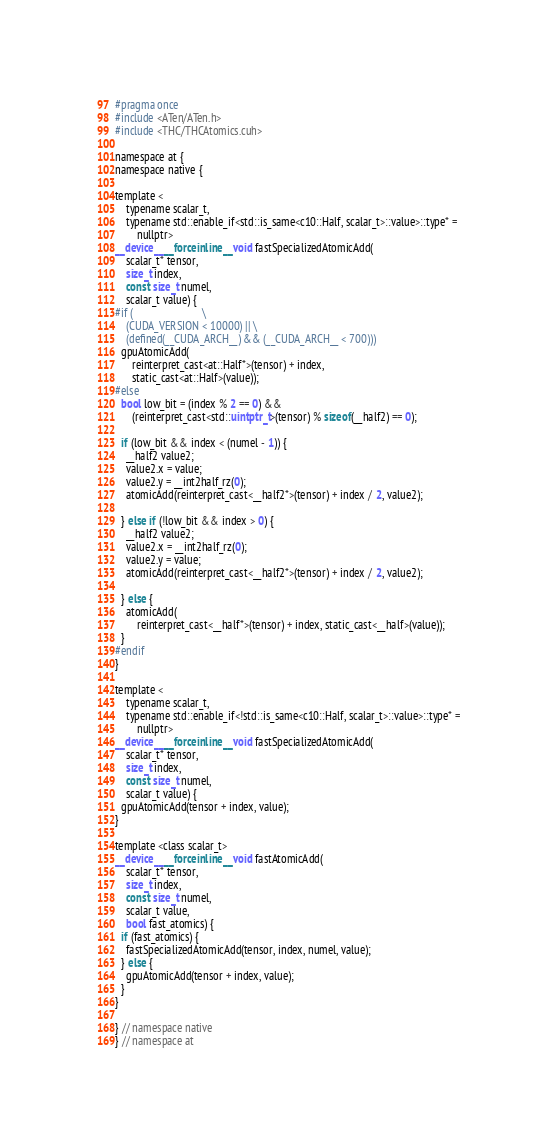<code> <loc_0><loc_0><loc_500><loc_500><_Cuda_>#pragma once
#include <ATen/ATen.h>
#include <THC/THCAtomics.cuh>

namespace at {
namespace native {

template <
    typename scalar_t,
    typename std::enable_if<std::is_same<c10::Half, scalar_t>::value>::type* =
        nullptr>
__device__ __forceinline__ void fastSpecializedAtomicAdd(
    scalar_t* tensor,
    size_t index,
    const size_t numel,
    scalar_t value) {
#if (                         \
    (CUDA_VERSION < 10000) || \
    (defined(__CUDA_ARCH__) && (__CUDA_ARCH__ < 700)))
  gpuAtomicAdd(
      reinterpret_cast<at::Half*>(tensor) + index,
      static_cast<at::Half>(value));
#else
  bool low_bit = (index % 2 == 0) &&
      (reinterpret_cast<std::uintptr_t>(tensor) % sizeof(__half2) == 0);

  if (low_bit && index < (numel - 1)) {
    __half2 value2;
    value2.x = value;
    value2.y = __int2half_rz(0);
    atomicAdd(reinterpret_cast<__half2*>(tensor) + index / 2, value2);

  } else if (!low_bit && index > 0) {
    __half2 value2;
    value2.x = __int2half_rz(0);
    value2.y = value;
    atomicAdd(reinterpret_cast<__half2*>(tensor) + index / 2, value2);

  } else {
    atomicAdd(
        reinterpret_cast<__half*>(tensor) + index, static_cast<__half>(value));
  }
#endif
}

template <
    typename scalar_t,
    typename std::enable_if<!std::is_same<c10::Half, scalar_t>::value>::type* =
        nullptr>
__device__ __forceinline__ void fastSpecializedAtomicAdd(
    scalar_t* tensor,
    size_t index,
    const size_t numel,
    scalar_t value) {
  gpuAtomicAdd(tensor + index, value);
}

template <class scalar_t>
__device__ __forceinline__ void fastAtomicAdd(
    scalar_t* tensor,
    size_t index,
    const size_t numel,
    scalar_t value,
    bool fast_atomics) {
  if (fast_atomics) {
    fastSpecializedAtomicAdd(tensor, index, numel, value);
  } else {
    gpuAtomicAdd(tensor + index, value);
  }
}

} // namespace native
} // namespace at
</code> 